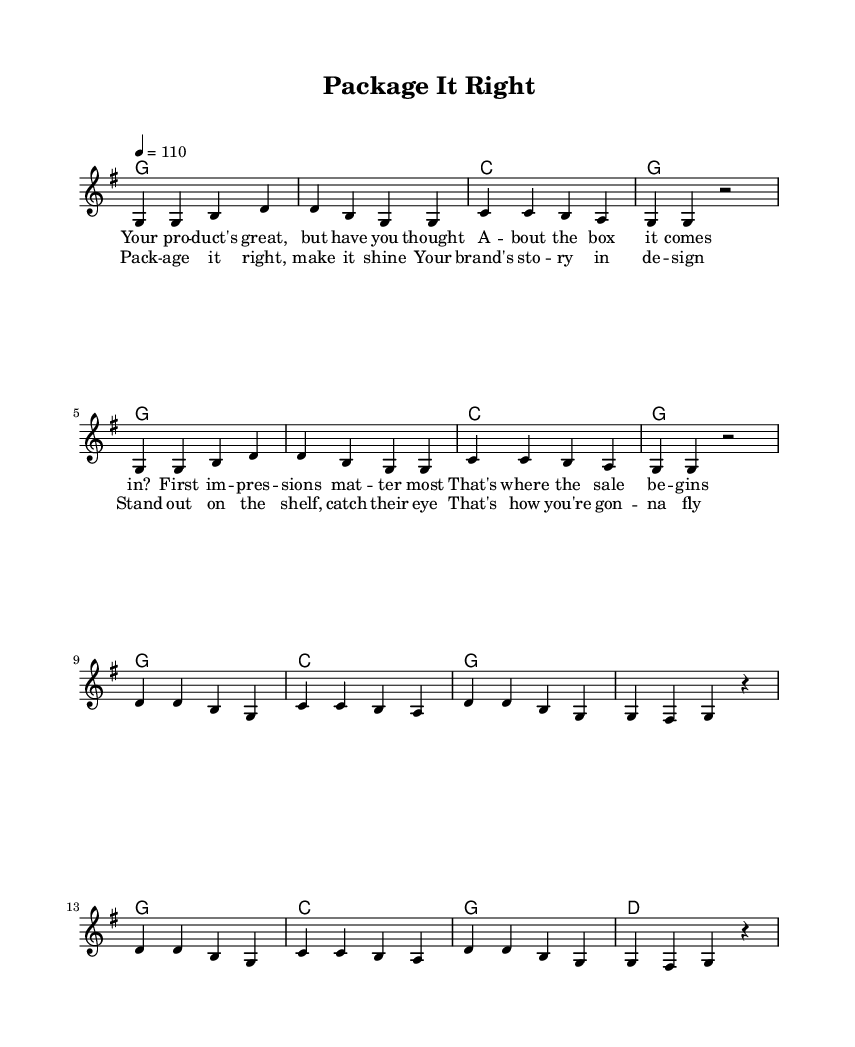What is the key signature of this music? The key signature is G major, which has one sharp (F#).
Answer: G major What is the time signature of the piece? The time signature is 4/4, indicating four beats per measure.
Answer: 4/4 What is the tempo marking given in the score? The tempo marking is 4 = 110, indicating the speed at which the piece should be played.
Answer: 110 How many measures are in the verse section? The verse section consists of 8 measures, as indicated by the repeated musical phrases.
Answer: 8 What is the primary theme addressed in the lyrics? The lyrics focus on the importance of packaging and branding in marketing a product.
Answer: Packaging What musical form does this piece utilize? This piece uses a verse-chorus form, alternating between verses and a repeated chorus.
Answer: Verse-chorus What is the final chord in the chorus? The final chord in the chorus is D major, which creates a resolution at the end of the section.
Answer: D 